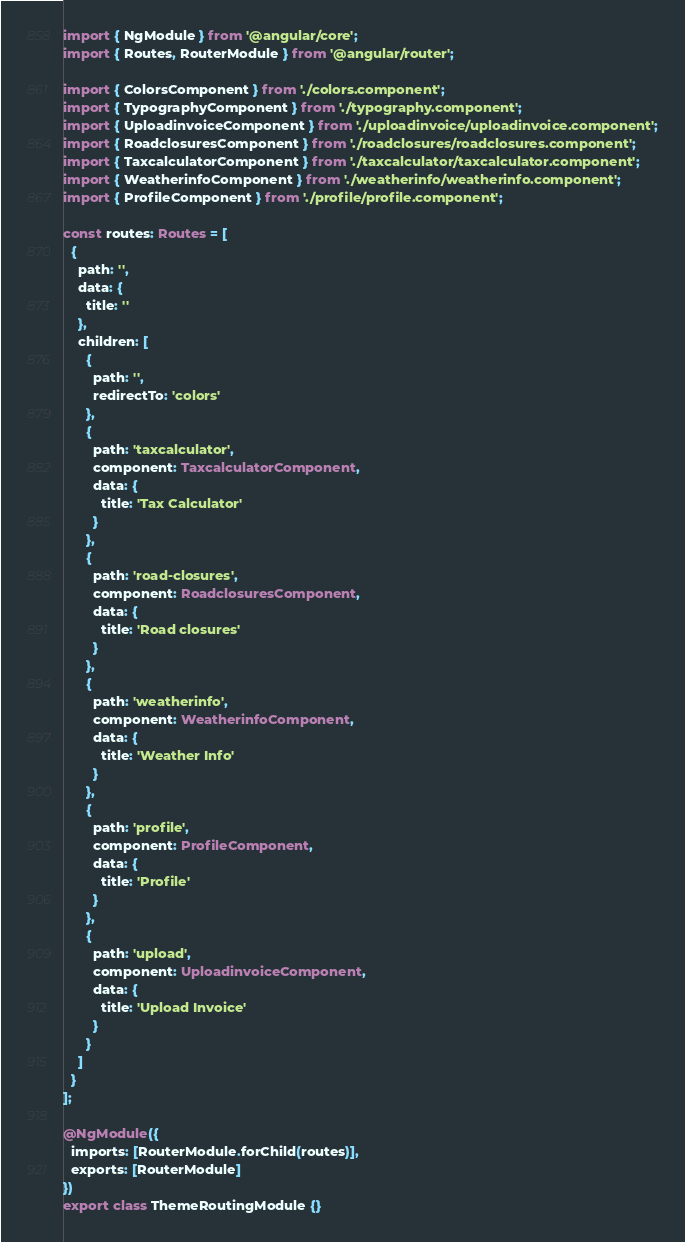<code> <loc_0><loc_0><loc_500><loc_500><_TypeScript_>import { NgModule } from '@angular/core';
import { Routes, RouterModule } from '@angular/router';

import { ColorsComponent } from './colors.component';
import { TypographyComponent } from './typography.component';
import { UploadinvoiceComponent } from './uploadinvoice/uploadinvoice.component';
import { RoadclosuresComponent } from './roadclosures/roadclosures.component';
import { TaxcalculatorComponent } from './taxcalculator/taxcalculator.component';
import { WeatherinfoComponent } from './weatherinfo/weatherinfo.component';
import { ProfileComponent } from './profile/profile.component';

const routes: Routes = [
  {
    path: '',
    data: {
      title: ''
    },
    children: [
      {
        path: '',
        redirectTo: 'colors'
      },
      {
        path: 'taxcalculator',
        component: TaxcalculatorComponent,
        data: {
          title: 'Tax Calculator'
        }
      },
      {
        path: 'road-closures',
        component: RoadclosuresComponent,
        data: {
          title: 'Road closures'
        }
      },
      {
        path: 'weatherinfo',
        component: WeatherinfoComponent,
        data: {
          title: 'Weather Info'
        }
      },
      {
        path: 'profile',
        component: ProfileComponent,
        data: {
          title: 'Profile'
        }
      },
      {
        path: 'upload',
        component: UploadinvoiceComponent,
        data: {
          title: 'Upload Invoice'
        }
      }
    ]
  }
];

@NgModule({
  imports: [RouterModule.forChild(routes)],
  exports: [RouterModule]
})
export class ThemeRoutingModule {}
</code> 